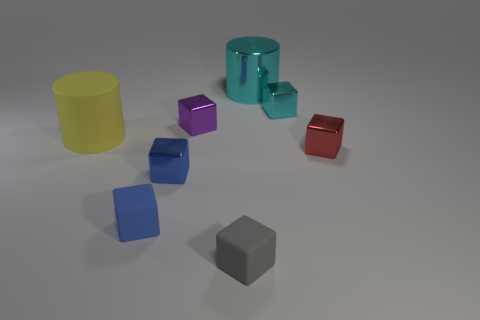Are there any other things of the same color as the matte cylinder?
Your answer should be very brief. No. There is a big shiny thing; does it have the same color as the small metallic cube behind the purple shiny cube?
Give a very brief answer. Yes. There is a large object to the right of the large matte object; is it the same shape as the gray thing?
Offer a very short reply. No. Is there a shiny object that has the same size as the gray cube?
Your response must be concise. Yes. There is a large yellow object; does it have the same shape as the cyan object that is right of the large metal object?
Give a very brief answer. No. What shape is the tiny shiny thing that is the same color as the metallic cylinder?
Provide a short and direct response. Cube. Are there fewer small gray matte things behind the small blue metal block than blue matte cubes?
Give a very brief answer. Yes. Does the large rubber thing have the same shape as the small gray object?
Your answer should be very brief. No. There is a cyan cube that is the same material as the purple object; what size is it?
Provide a short and direct response. Small. Are there fewer gray matte balls than purple metallic objects?
Make the answer very short. Yes. 